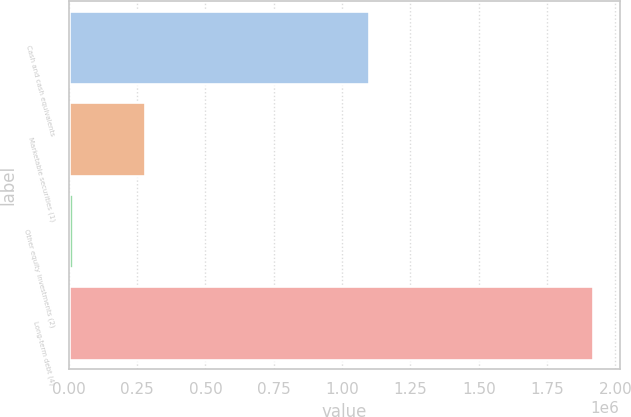Convert chart. <chart><loc_0><loc_0><loc_500><loc_500><bar_chart><fcel>Cash and cash equivalents<fcel>Marketable securities (1)<fcel>Other equity investments (2)<fcel>Long-term debt (4)<nl><fcel>1.09914e+06<fcel>278390<fcel>14831<fcel>1.91947e+06<nl></chart> 